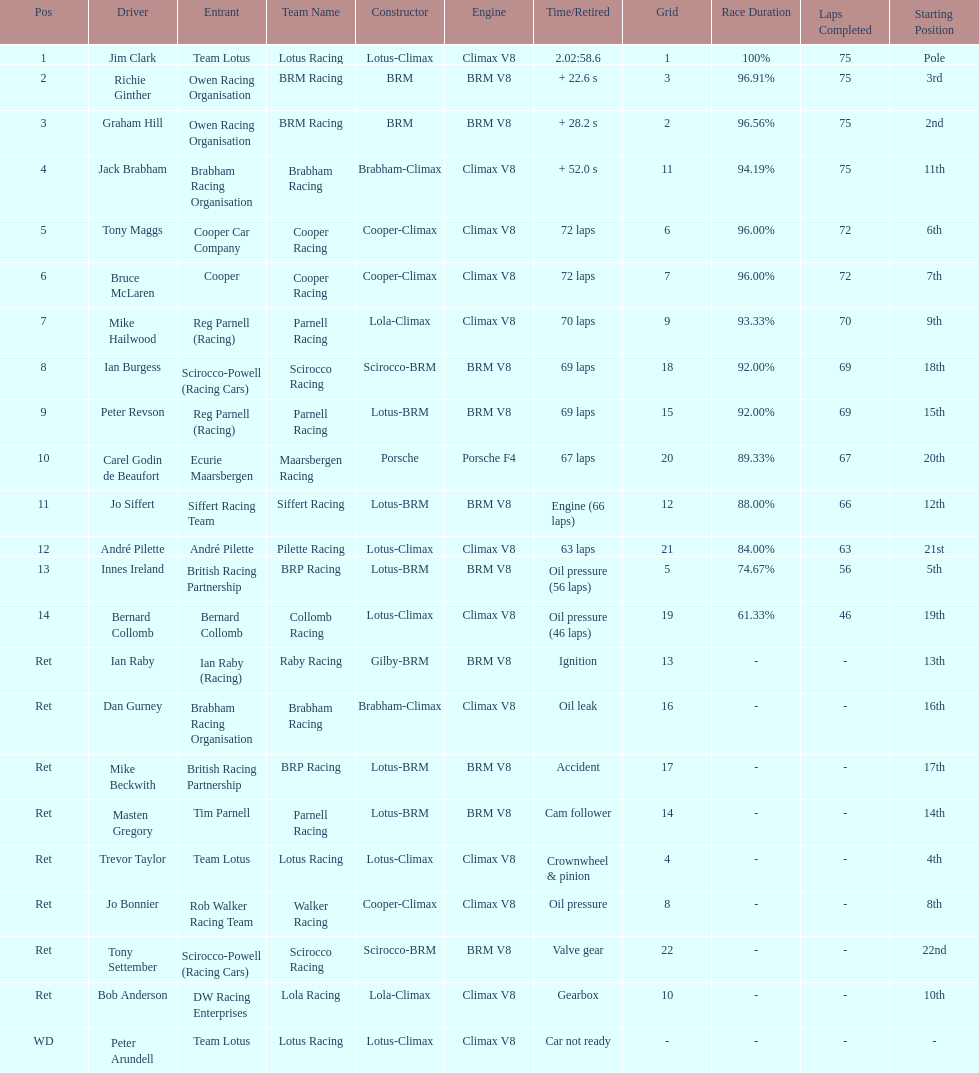What country had the least number of drivers, germany or the uk? Germany. 